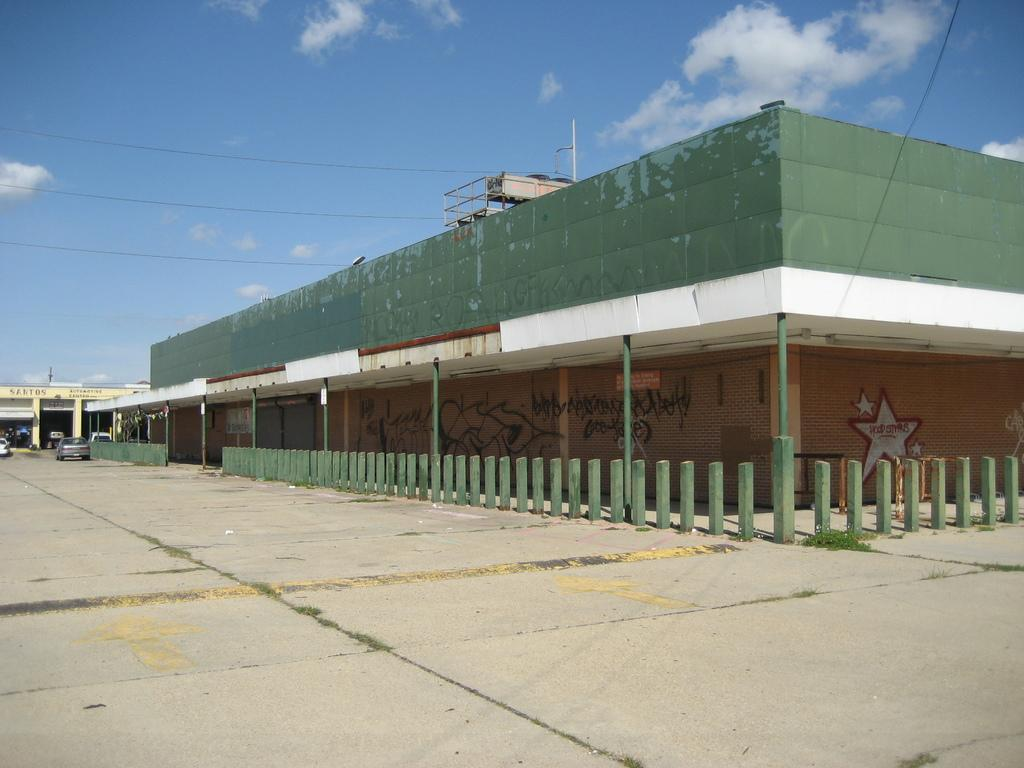What is located in the foreground of the image? There is a building, a fence, shops, and vehicles on the road in the foreground of the image. What type of structure is visible in the foreground? The building is visible in the foreground of the image. What can be seen in the background of the image? The sky is blue in the background of the image. When was the image taken? The image was taken during the day. Can you see any fish swimming in the image? There are no fish present in the image. What type of pen is being used to write on the building in the image? There is no pen or writing visible on the building in the image. 